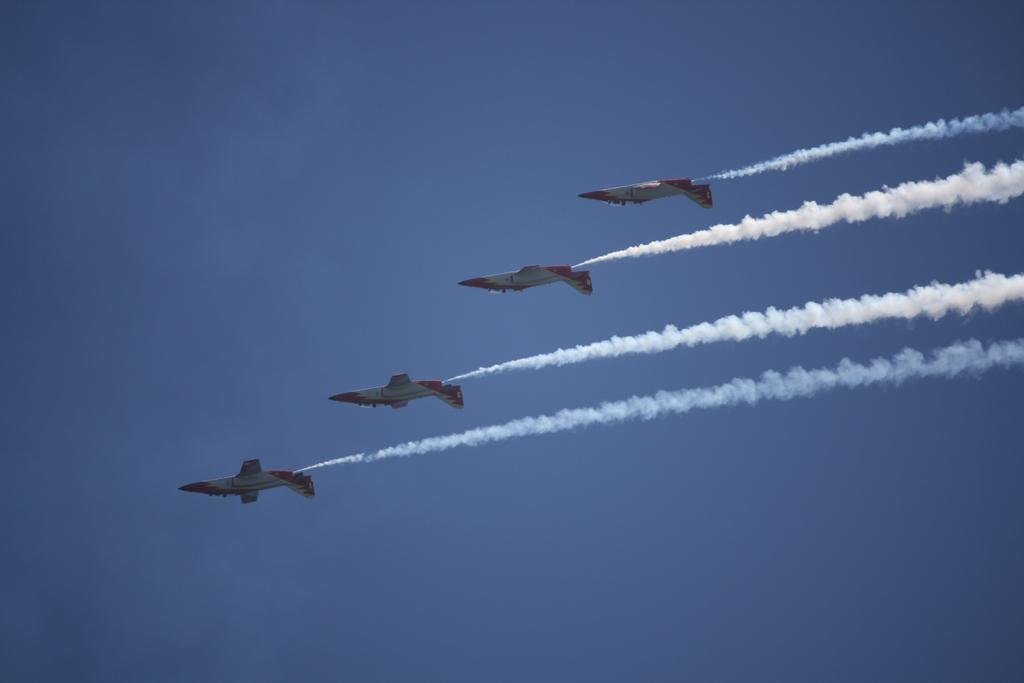How many aircrafts are present in the image? There are four aircrafts in the image. What are the aircrafts doing in the image? The aircrafts are flying in the air. What is coming out of the aircrafts? The aircrafts are ejecting smoke. What can be seen in the background of the image? The sky is visible in the background of the image. What is the color of the sky in the image? The color of the sky is blue. Where is the zebra located in the image? There is no zebra present in the image. What type of industry is depicted in the image? There is no industry depicted in the image; it features four aircrafts flying in the air and ejecting smoke. 